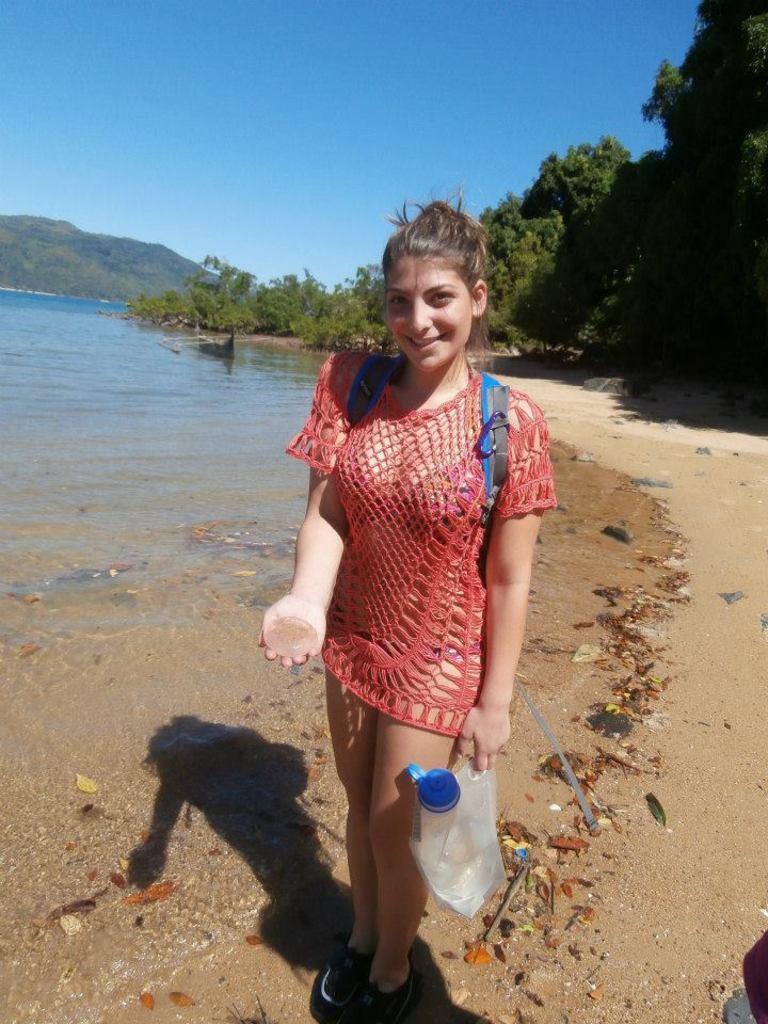How would you summarize this image in a sentence or two? In this picture we can see a woman and in the background we can see water, trees, mountain, sky. 